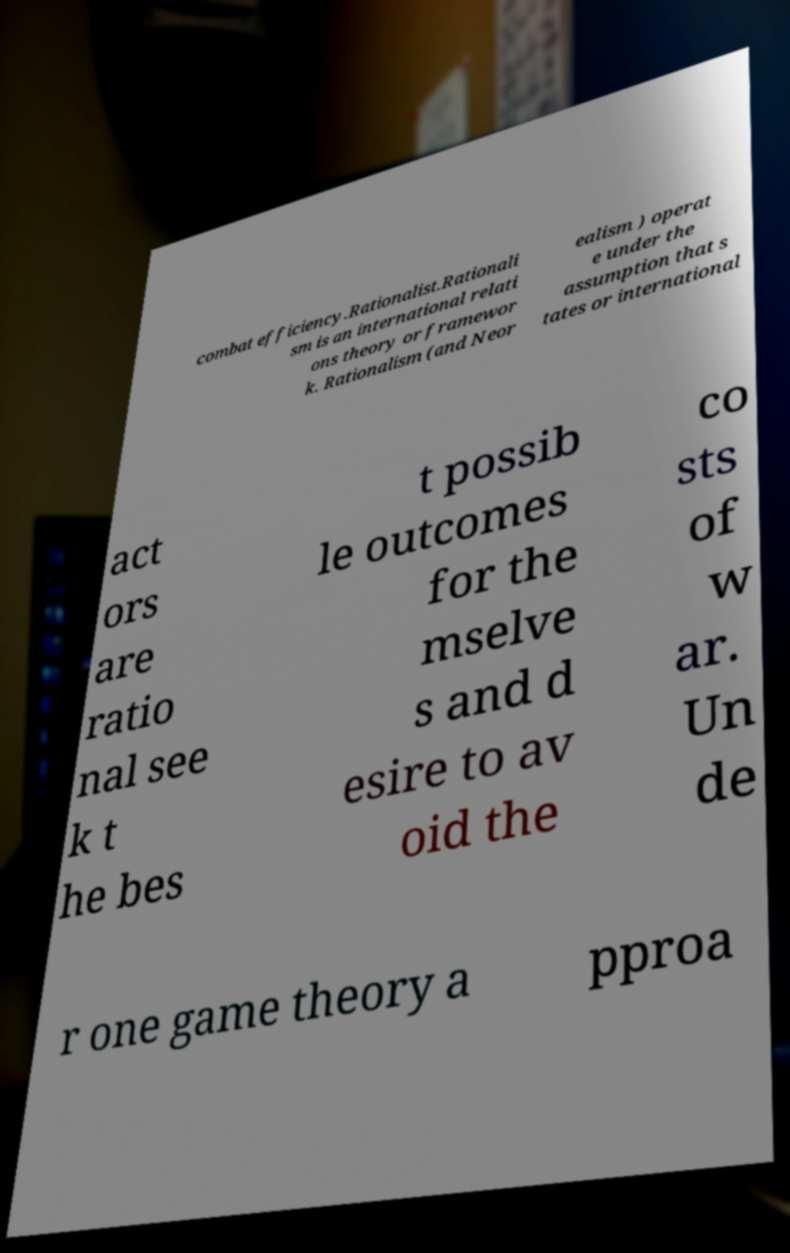Please read and relay the text visible in this image. What does it say? combat efficiency.Rationalist.Rationali sm is an international relati ons theory or framewor k. Rationalism (and Neor ealism ) operat e under the assumption that s tates or international act ors are ratio nal see k t he bes t possib le outcomes for the mselve s and d esire to av oid the co sts of w ar. Un de r one game theory a pproa 